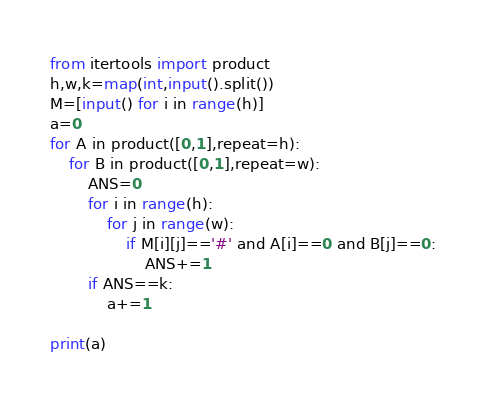<code> <loc_0><loc_0><loc_500><loc_500><_Python_>from itertools import product
h,w,k=map(int,input().split())
M=[input() for i in range(h)]
a=0
for A in product([0,1],repeat=h):
    for B in product([0,1],repeat=w):
        ANS=0
        for i in range(h):
            for j in range(w):
                if M[i][j]=='#' and A[i]==0 and B[j]==0:
                    ANS+=1
        if ANS==k:
            a+=1

print(a)
</code> 